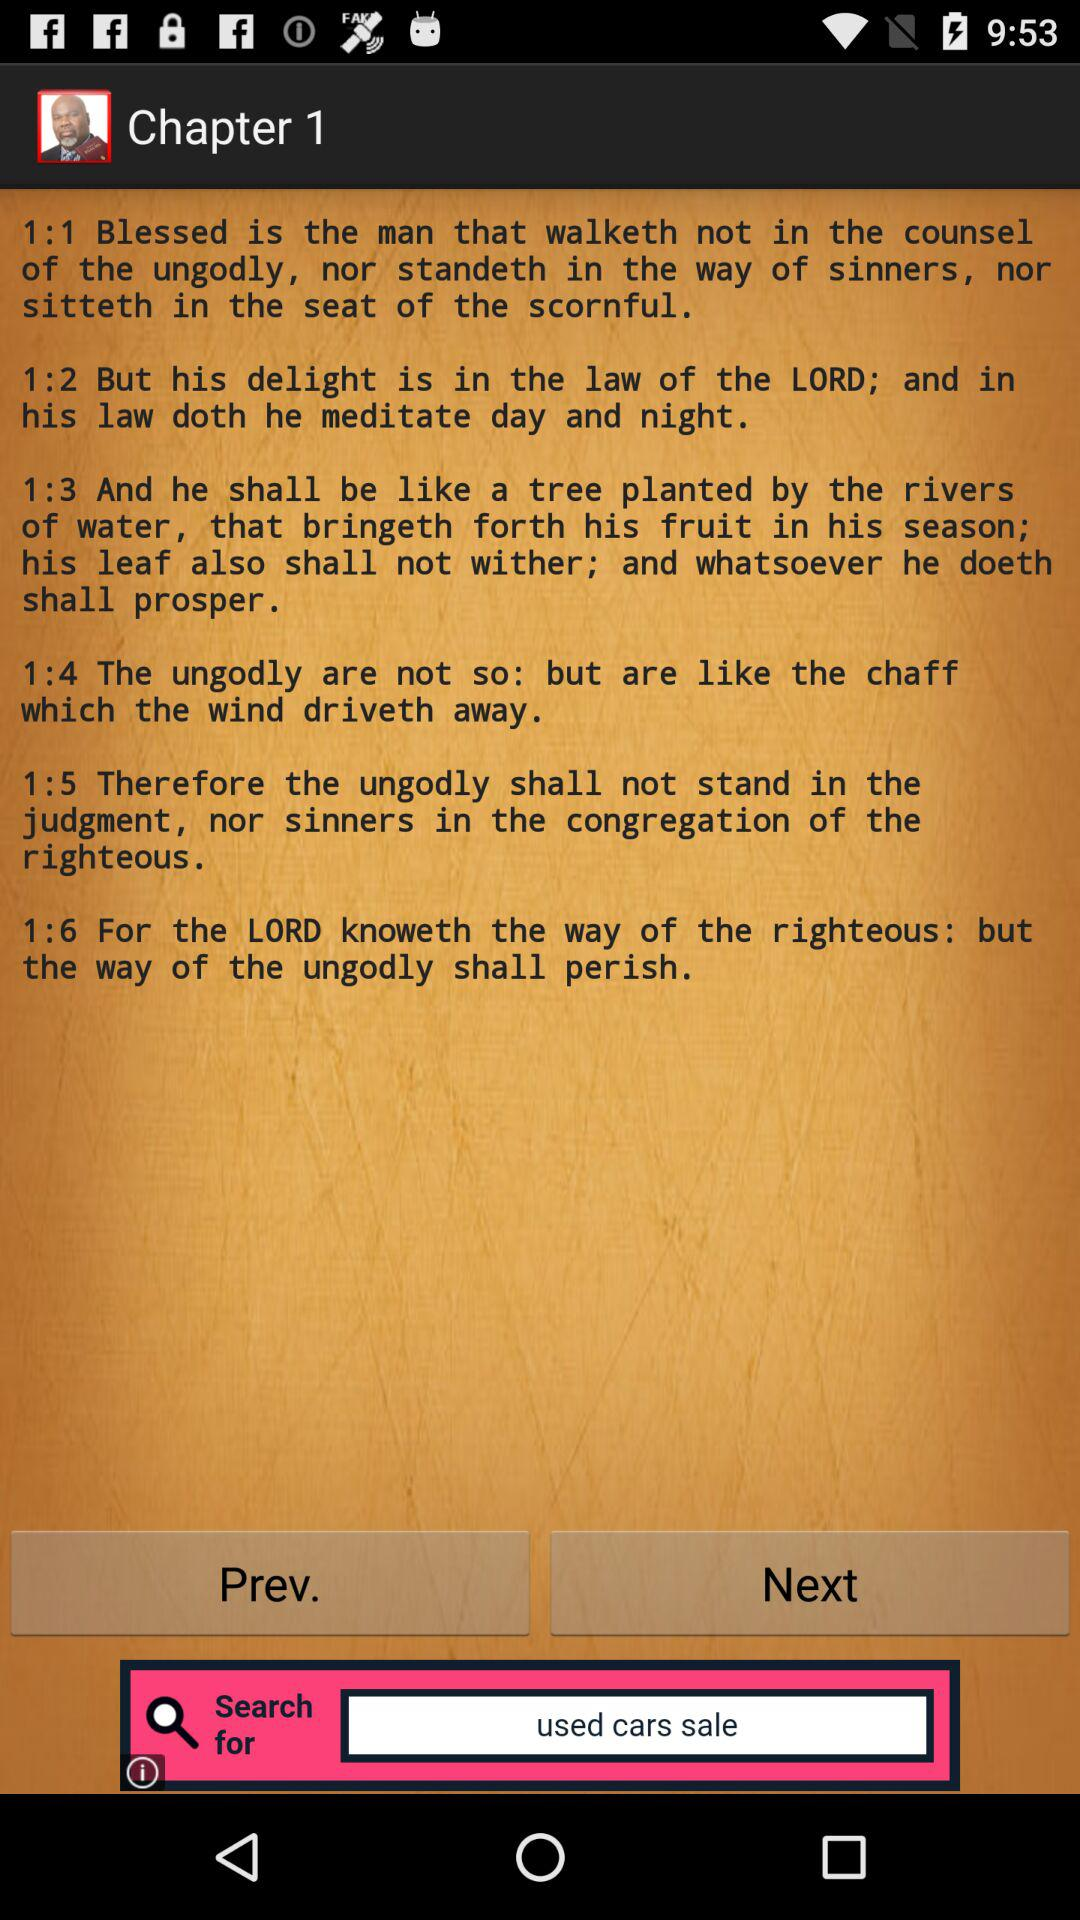What chapter is currently shown on the screen? The screen is currently showing chapter 1. 